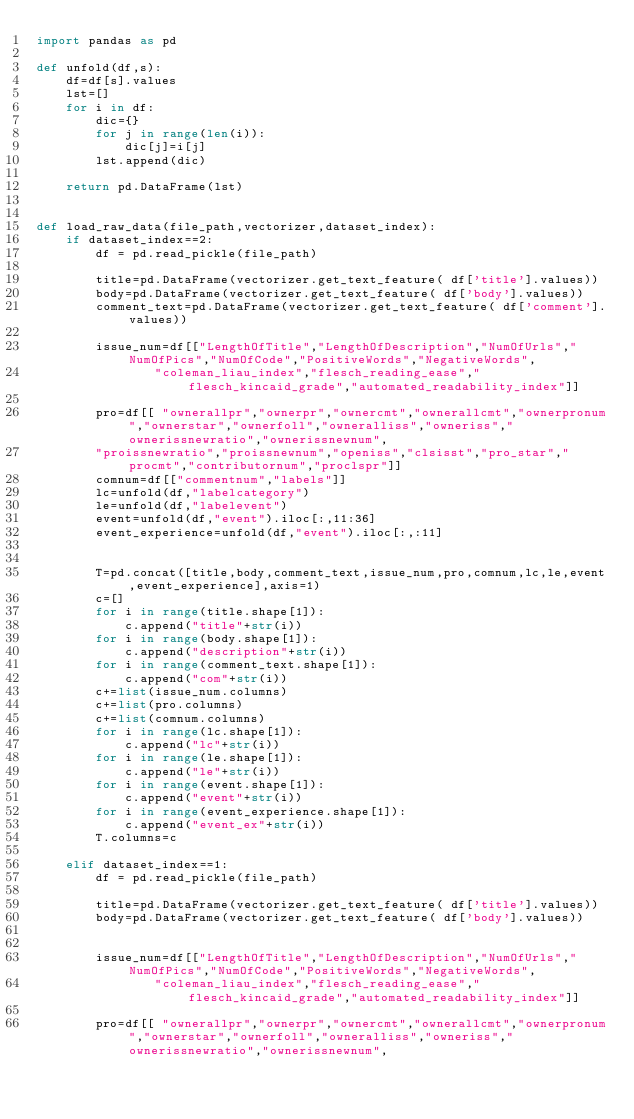Convert code to text. <code><loc_0><loc_0><loc_500><loc_500><_Python_>import pandas as pd

def unfold(df,s):
    df=df[s].values
    lst=[]
    for i in df:
        dic={}
        for j in range(len(i)):
            dic[j]=i[j]
        lst.append(dic)

    return pd.DataFrame(lst)


def load_raw_data(file_path,vectorizer,dataset_index):
    if dataset_index==2:
        df = pd.read_pickle(file_path)
        
        title=pd.DataFrame(vectorizer.get_text_feature( df['title'].values))
        body=pd.DataFrame(vectorizer.get_text_feature( df['body'].values))
        comment_text=pd.DataFrame(vectorizer.get_text_feature( df['comment'].values))

        issue_num=df[["LengthOfTitle","LengthOfDescription","NumOfUrls","NumOfPics","NumOfCode","PositiveWords","NegativeWords",
                "coleman_liau_index","flesch_reading_ease","flesch_kincaid_grade","automated_readability_index"]]

        pro=df[[ "ownerallpr","ownerpr","ownercmt","ownerallcmt","ownerpronum","ownerstar","ownerfoll","owneralliss","owneriss","ownerissnewratio","ownerissnewnum",
        "proissnewratio","proissnewnum","openiss","clsisst","pro_star","procmt","contributornum","proclspr"]]
        comnum=df[["commentnum","labels"]]
        lc=unfold(df,"labelcategory")
        le=unfold(df,"labelevent")
        event=unfold(df,"event").iloc[:,11:36]
        event_experience=unfold(df,"event").iloc[:,:11]


        T=pd.concat([title,body,comment_text,issue_num,pro,comnum,lc,le,event,event_experience],axis=1)
        c=[]
        for i in range(title.shape[1]):
            c.append("title"+str(i))
        for i in range(body.shape[1]):
            c.append("description"+str(i))
        for i in range(comment_text.shape[1]):
            c.append("com"+str(i))
        c+=list(issue_num.columns)
        c+=list(pro.columns)
        c+=list(comnum.columns)
        for i in range(lc.shape[1]):
            c.append("lc"+str(i))
        for i in range(le.shape[1]):
            c.append("le"+str(i))
        for i in range(event.shape[1]):
            c.append("event"+str(i))
        for i in range(event_experience.shape[1]):
            c.append("event_ex"+str(i))   
        T.columns=c

    elif dataset_index==1:
        df = pd.read_pickle(file_path)
        
        title=pd.DataFrame(vectorizer.get_text_feature( df['title'].values))
        body=pd.DataFrame(vectorizer.get_text_feature( df['body'].values))
    
        
        issue_num=df[["LengthOfTitle","LengthOfDescription","NumOfUrls","NumOfPics","NumOfCode","PositiveWords","NegativeWords",
                "coleman_liau_index","flesch_reading_ease","flesch_kincaid_grade","automated_readability_index"]]

        pro=df[[ "ownerallpr","ownerpr","ownercmt","ownerallcmt","ownerpronum","ownerstar","ownerfoll","owneralliss","owneriss","ownerissnewratio","ownerissnewnum",</code> 